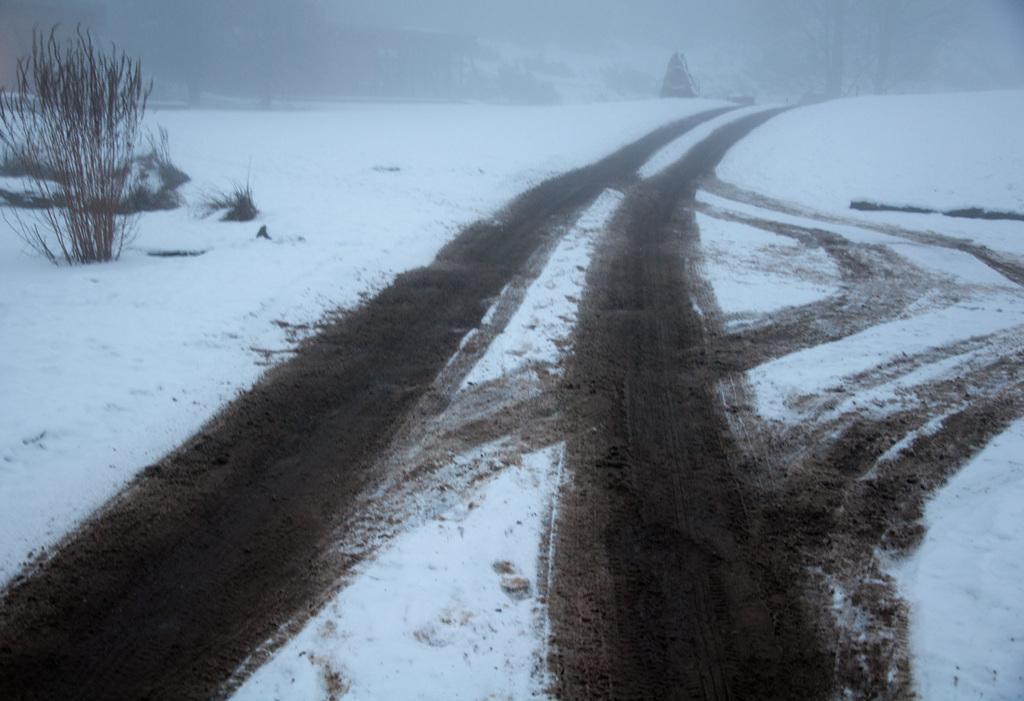In one or two sentences, can you explain what this image depicts? On the ground there is snow. Also there are marks of tires on the ground. Also there are few plants. In the background there are trees and it is looking blur. 